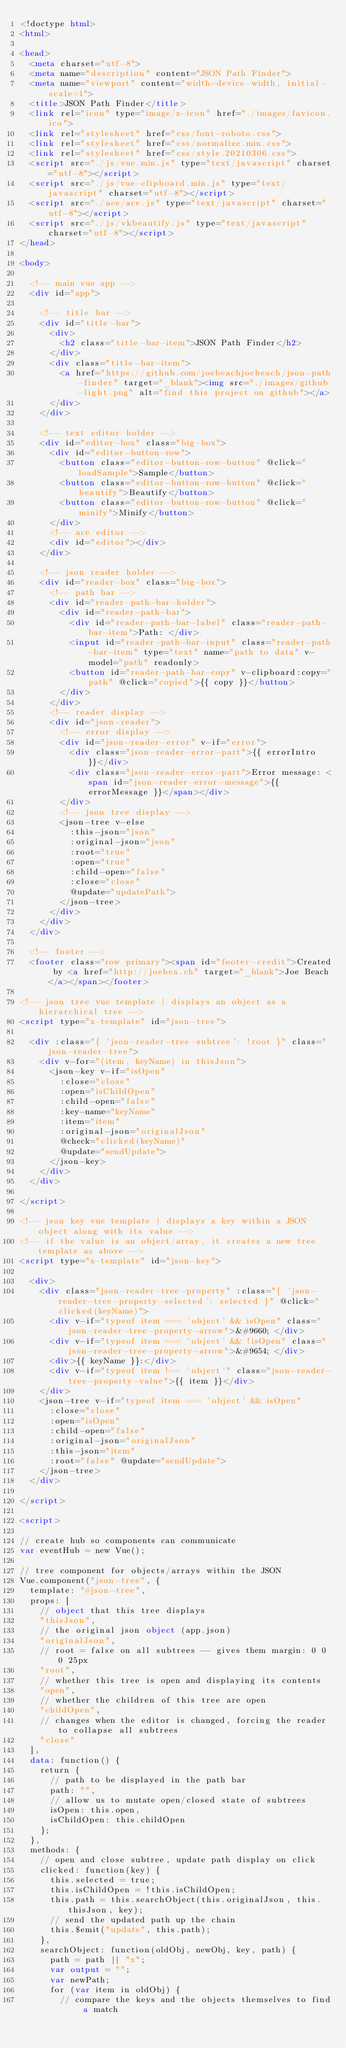<code> <loc_0><loc_0><loc_500><loc_500><_HTML_><!doctype html>
<html>

<head>
  <meta charset="utf-8">
  <meta name="description" content="JSON Path Finder">
  <meta name="viewport" content="width=device-width, initial-scale=1">
  <title>JSON Path Finder</title>
  <link rel="icon" type="image/x-icon" href="./images/favicon.ico">
  <link rel="stylesheet" href="css/font-roboto.css">
  <link rel="stylesheet" href="css/normalize.min.css">
  <link rel="stylesheet" href="css/style.20210306.css">
  <script src="./js/vue.min.js" type="text/javascript" charset="utf-8"></script>
  <script src="./js/vue-clipboard.min.js" type="text/javascript" charset="utf-8"></script>
  <script src="./ace/ace.js" type="text/javascript" charset="utf-8"></script>
  <script src="./js/vkbeautify.js" type="text/javascript" charset="utf-8"></script>
</head>

<body>

  <!-- main vue app -->
  <div id="app">

    <!-- title bar -->
    <div id="title-bar">
      <div>
        <h2 class="title-bar-item">JSON Path Finder</h2>
      </div>
      <div class="title-bar-item">
        <a href="https://github.com/joebeachjoebeach/json-path-finder" target="_blank"><img src="./images/github-light.png" alt="find this project on github"></a>
      </div>
    </div>

    <!-- text editor holder -->
    <div id="editor-box" class="big-box">
      <div id="editor-button-row">
        <button class="editor-button-row-button" @click="loadSample">Sample</button>
        <button class="editor-button-row-button" @click="beautify">Beautify</button>
        <button class="editor-button-row-button" @click="minify">Minify</button>
      </div>
      <!-- ace editor -->
      <div id="editor"></div>
    </div>

    <!-- json reader holder -->
    <div id="reader-box" class="big-box">
      <!-- path bar -->
      <div id="reader-path-bar-holder">
        <div id="reader-path-bar">
          <div id="reader-path-bar-label" class="reader-path-bar-item">Path: </div>
          <input id="reader-path-bar-input" class="reader-path-bar-item" type="text" name="path to data" v-model="path" readonly>
          <button id="reader-path-bar-copy" v-clipboard:copy="path" @click="copied">{{ copy }}</button>
        </div>
      </div>
      <!-- reader display -->
      <div id="json-reader">
        <!-- error display -->
        <div id="json-reader-error" v-if="error">
          <div class="json-reader-error-part">{{ errorIntro }}</div>
          <div class="json-reader-error-part">Error message: <span id="json-reader-error-message">{{ errorMessage }}</span></div>
        </div>
        <!-- json tree display -->
        <json-tree v-else 
          :this-json="json"
          :original-json="json"
          :root="true"
          :open="true"
          :child-open="false"
          :close="close"
          @update="updatePath">
        </json-tree>
      </div>
    </div>
  </div>

  <!-- footer -->
  <footer class="row primary"><span id="footer-credit">Created by <a href="http://joebea.ch" target="_blank">Joe Beach</a></span></footer>

<!-- json tree vue template | displays an object as a hierarchical tree -->
<script type="x-template" id="json-tree">

  <div :class="{ 'json-reader-tree-subtree': !root }" class="json-reader-tree">
    <div v-for="(item, keyName) in thisJson">
      <json-key v-if="isOpen"
        :close="close"
        :open="isChildOpen"
        :child-open="false"
        :key-name="keyName"
        :item="item"
        :original-json="originalJson"
        @check="clicked(keyName)"
        @update="sendUpdate">
      </json-key>
    </div>
  </div>

</script>

<!-- json key vue template | displays a key within a JSON object along with its value -->
<!-- if the value is an object/array, it creates a new tree template as above -->
<script type="x-template" id="json-key">

  <div>
    <div class="json-reader-tree-property" :class="{ 'json-reader-tree-property-selected': selected }" @click="clicked(keyName)">
      <div v-if="typeof item === 'object' && isOpen" class="json-reader-tree-property-arrow">&#9660; </div>
      <div v-if="typeof item === 'object' && !isOpen" class="json-reader-tree-property-arrow">&#9654; </div>
      <div>{{ keyName }}:</div>
      <div v-if="typeof item !== 'object'" class="json-reader-tree-property-value">{{ item }}</div>
    </div>
    <json-tree v-if="typeof item === 'object' && isOpen"
      :close="close"
      :open="isOpen"
      :child-open="false"
      :original-json="originalJson"
      :this-json="item"
      :root="false" @update="sendUpdate">
    </json-tree>
  </div>

</script>

<script>

// create hub so components can communicate
var eventHub = new Vue();

// tree component for objects/arrays within the JSON
Vue.component("json-tree", {
  template: "#json-tree",
  props: [
    // object that this tree displays
    "thisJson",
    // the original json object (app.json)
    "originalJson",
    // root = false on all subtrees -- gives them margin: 0 0 0 25px
    "root",
    // whether this tree is open and displaying its contents
    "open",
    // whether the children of this tree are open
    "childOpen",
    // changes when the editor is changed, forcing the reader to collapse all subtrees
    "close"
  ],
  data: function() {
    return {
      // path to be displayed in the path bar
      path: "",
      // allow us to mutate open/closed state of subtrees
      isOpen: this.open,
      isChildOpen: this.childOpen
    };
  },
  methods: {
    // open and close subtree, update path display on click
    clicked: function(key) {
      this.selected = true;
      this.isChildOpen = !this.isChildOpen;
      this.path = this.searchObject(this.originalJson, this.thisJson, key);
      // send the updated path up the chain
      this.$emit("update", this.path);
    },
    searchObject: function(oldObj, newObj, key, path) {
      path = path || "x";
      var output = "";
      var newPath;
      for (var item in oldObj) {
        // compare the keys and the objects themselves to find a match</code> 